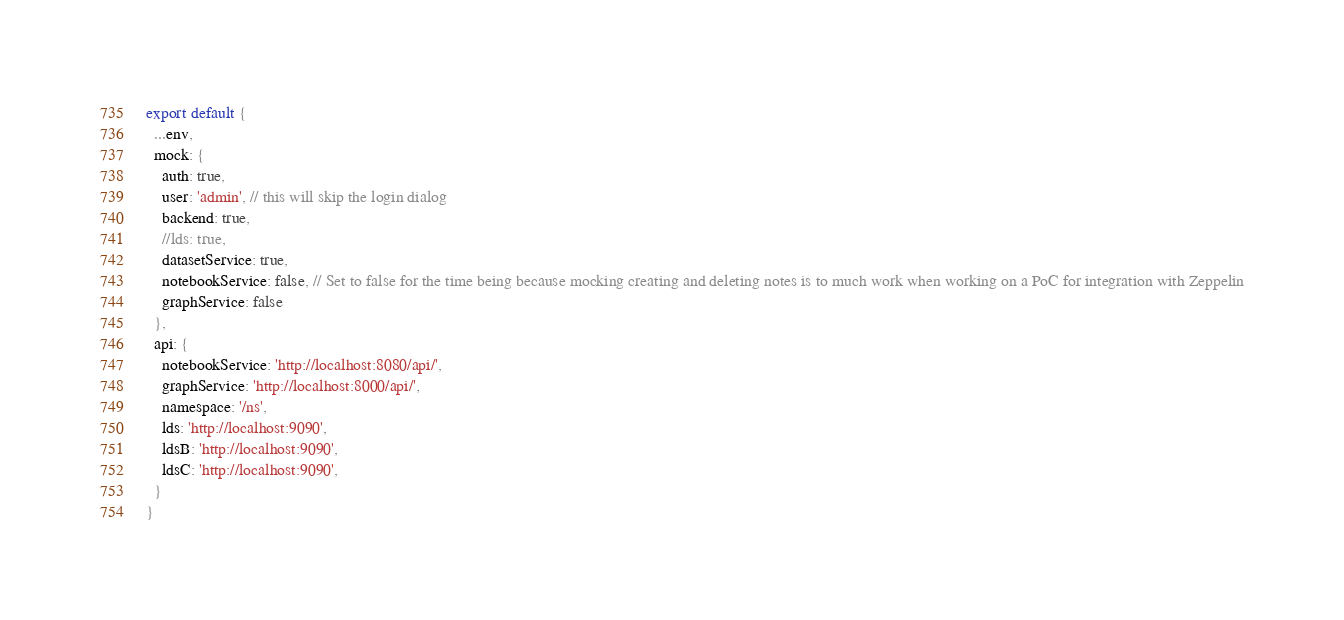<code> <loc_0><loc_0><loc_500><loc_500><_JavaScript_>
export default {
  ...env,
  mock: {
    auth: true,
    user: 'admin', // this will skip the login dialog
    backend: true,
    //lds: true,
    datasetService: true,
    notebookService: false, // Set to false for the time being because mocking creating and deleting notes is to much work when working on a PoC for integration with Zeppelin
    graphService: false
  },
  api: {
    notebookService: 'http://localhost:8080/api/',
    graphService: 'http://localhost:8000/api/',
    namespace: '/ns',
    lds: 'http://localhost:9090',
    ldsB: 'http://localhost:9090',
    ldsC: 'http://localhost:9090',
  }
}</code> 